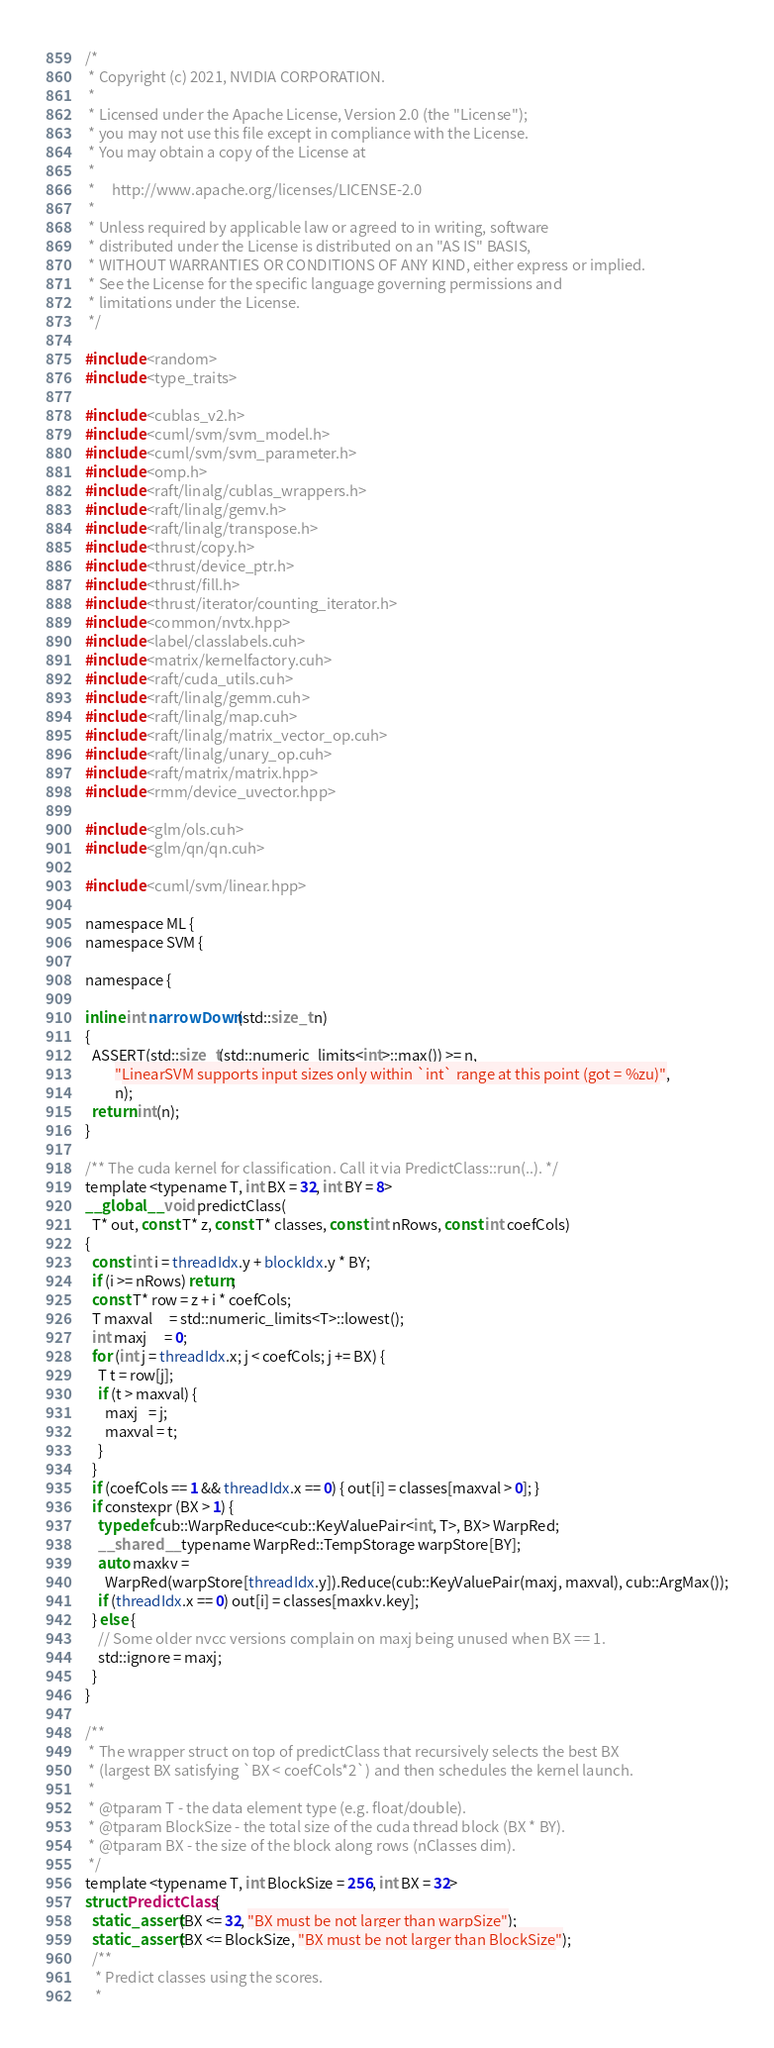<code> <loc_0><loc_0><loc_500><loc_500><_Cuda_>/*
 * Copyright (c) 2021, NVIDIA CORPORATION.
 *
 * Licensed under the Apache License, Version 2.0 (the "License");
 * you may not use this file except in compliance with the License.
 * You may obtain a copy of the License at
 *
 *     http://www.apache.org/licenses/LICENSE-2.0
 *
 * Unless required by applicable law or agreed to in writing, software
 * distributed under the License is distributed on an "AS IS" BASIS,
 * WITHOUT WARRANTIES OR CONDITIONS OF ANY KIND, either express or implied.
 * See the License for the specific language governing permissions and
 * limitations under the License.
 */

#include <random>
#include <type_traits>

#include <cublas_v2.h>
#include <cuml/svm/svm_model.h>
#include <cuml/svm/svm_parameter.h>
#include <omp.h>
#include <raft/linalg/cublas_wrappers.h>
#include <raft/linalg/gemv.h>
#include <raft/linalg/transpose.h>
#include <thrust/copy.h>
#include <thrust/device_ptr.h>
#include <thrust/fill.h>
#include <thrust/iterator/counting_iterator.h>
#include <common/nvtx.hpp>
#include <label/classlabels.cuh>
#include <matrix/kernelfactory.cuh>
#include <raft/cuda_utils.cuh>
#include <raft/linalg/gemm.cuh>
#include <raft/linalg/map.cuh>
#include <raft/linalg/matrix_vector_op.cuh>
#include <raft/linalg/unary_op.cuh>
#include <raft/matrix/matrix.hpp>
#include <rmm/device_uvector.hpp>

#include <glm/ols.cuh>
#include <glm/qn/qn.cuh>

#include <cuml/svm/linear.hpp>

namespace ML {
namespace SVM {

namespace {

inline int narrowDown(std::size_t n)
{
  ASSERT(std::size_t(std::numeric_limits<int>::max()) >= n,
         "LinearSVM supports input sizes only within `int` range at this point (got = %zu)",
         n);
  return int(n);
}

/** The cuda kernel for classification. Call it via PredictClass::run(..). */
template <typename T, int BX = 32, int BY = 8>
__global__ void predictClass(
  T* out, const T* z, const T* classes, const int nRows, const int coefCols)
{
  const int i = threadIdx.y + blockIdx.y * BY;
  if (i >= nRows) return;
  const T* row = z + i * coefCols;
  T maxval     = std::numeric_limits<T>::lowest();
  int maxj     = 0;
  for (int j = threadIdx.x; j < coefCols; j += BX) {
    T t = row[j];
    if (t > maxval) {
      maxj   = j;
      maxval = t;
    }
  }
  if (coefCols == 1 && threadIdx.x == 0) { out[i] = classes[maxval > 0]; }
  if constexpr (BX > 1) {
    typedef cub::WarpReduce<cub::KeyValuePair<int, T>, BX> WarpRed;
    __shared__ typename WarpRed::TempStorage warpStore[BY];
    auto maxkv =
      WarpRed(warpStore[threadIdx.y]).Reduce(cub::KeyValuePair(maxj, maxval), cub::ArgMax());
    if (threadIdx.x == 0) out[i] = classes[maxkv.key];
  } else {
    // Some older nvcc versions complain on maxj being unused when BX == 1.
    std::ignore = maxj;
  }
}

/**
 * The wrapper struct on top of predictClass that recursively selects the best BX
 * (largest BX satisfying `BX < coefCols*2`) and then schedules the kernel launch.
 *
 * @tparam T - the data element type (e.g. float/double).
 * @tparam BlockSize - the total size of the cuda thread block (BX * BY).
 * @tparam BX - the size of the block along rows (nClasses dim).
 */
template <typename T, int BlockSize = 256, int BX = 32>
struct PredictClass {
  static_assert(BX <= 32, "BX must be not larger than warpSize");
  static_assert(BX <= BlockSize, "BX must be not larger than BlockSize");
  /**
   * Predict classes using the scores.
   *</code> 